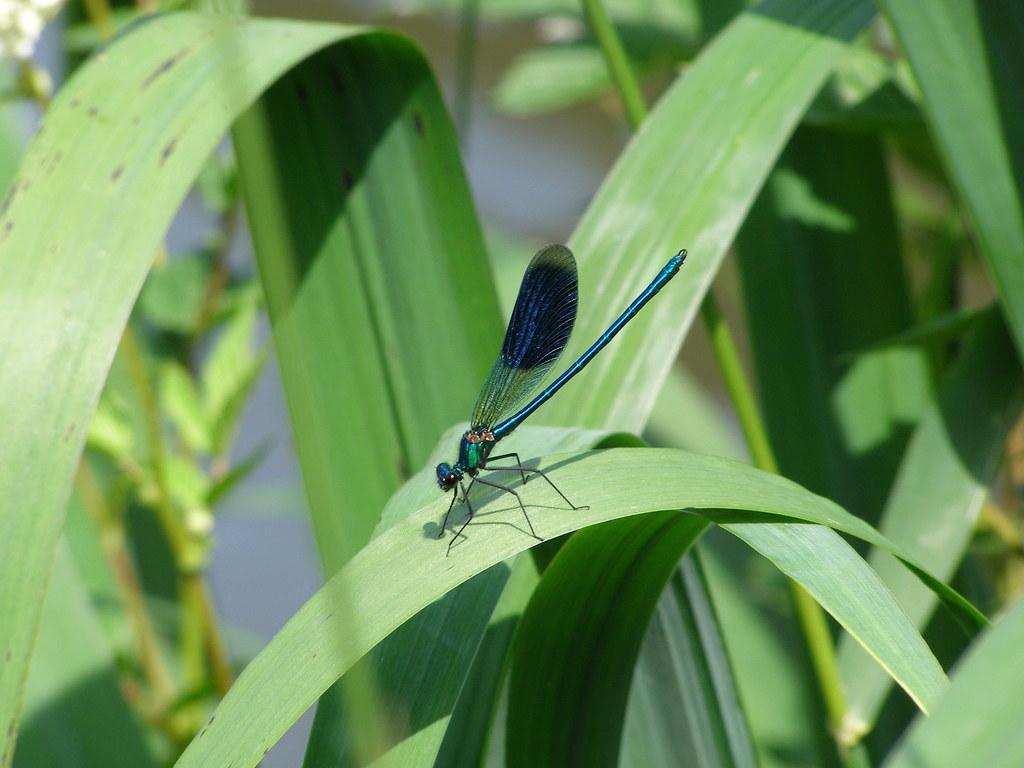Describe this image in one or two sentences. In this image we can see many plants. There is an insect sitting on the leaf. 